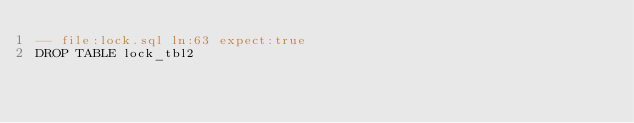<code> <loc_0><loc_0><loc_500><loc_500><_SQL_>-- file:lock.sql ln:63 expect:true
DROP TABLE lock_tbl2
</code> 